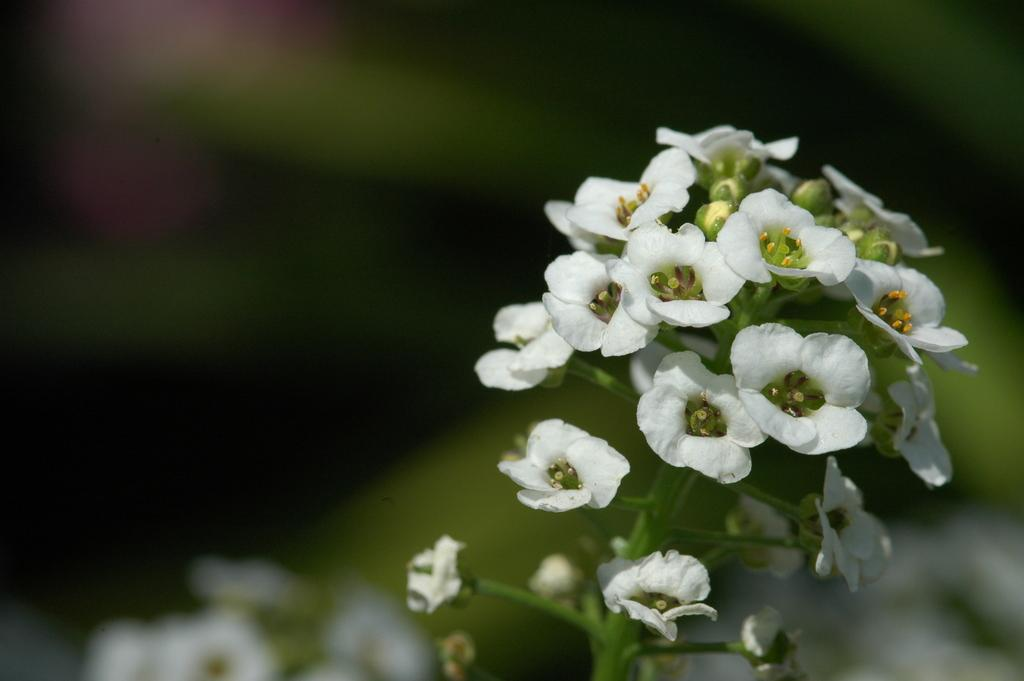What colors are the flowers in the image? The flowers in the image are white and green. What are the flowers growing on? The flowers are on plants. Can you describe the background of the image? The background of the image is blurred. How many rabbits are sitting on the son's account in the image? There are no rabbits or accounts present in the image; it features white and green flowers on plants with a blurred background. 